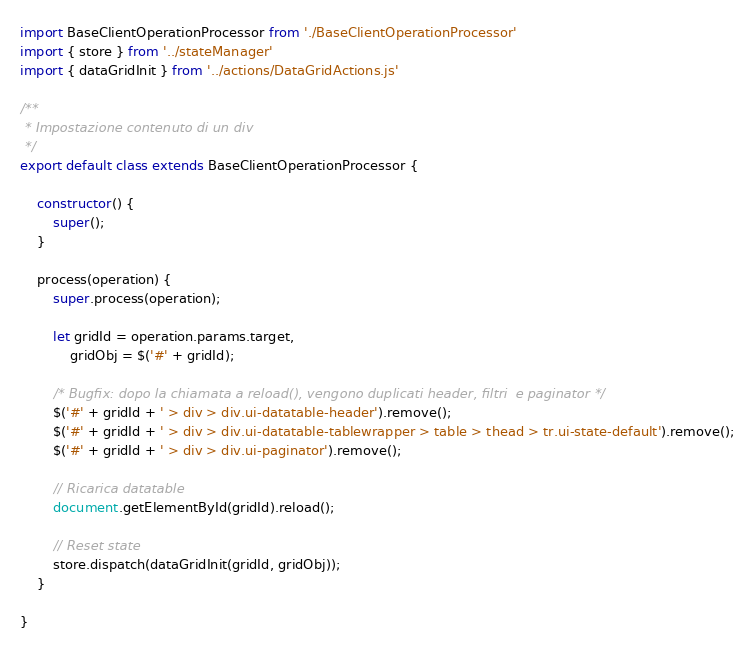<code> <loc_0><loc_0><loc_500><loc_500><_JavaScript_>import BaseClientOperationProcessor from './BaseClientOperationProcessor'
import { store } from '../stateManager'
import { dataGridInit } from '../actions/DataGridActions.js'  

/**
 * Impostazione contenuto di un div
 */
export default class extends BaseClientOperationProcessor {

    constructor() {
        super();
    }

    process(operation) {
        super.process(operation);
        
        let gridId = operation.params.target,
            gridObj = $('#' + gridId);

        /* Bugfix: dopo la chiamata a reload(), vengono duplicati header, filtri  e paginator */
        $('#' + gridId + ' > div > div.ui-datatable-header').remove();
        $('#' + gridId + ' > div > div.ui-datatable-tablewrapper > table > thead > tr.ui-state-default').remove();
        $('#' + gridId + ' > div > div.ui-paginator').remove();
        
        // Ricarica datatable
        document.getElementById(gridId).reload();

        // Reset state
        store.dispatch(dataGridInit(gridId, gridObj));
    }

}</code> 